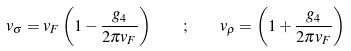<formula> <loc_0><loc_0><loc_500><loc_500>v _ { \sigma } = v _ { F } \left ( 1 - \frac { g _ { 4 } } { 2 \pi v _ { F } } \right ) \quad ; \quad v _ { \rho } = \left ( 1 + \frac { g _ { 4 } } { 2 \pi v _ { F } } \right )</formula> 